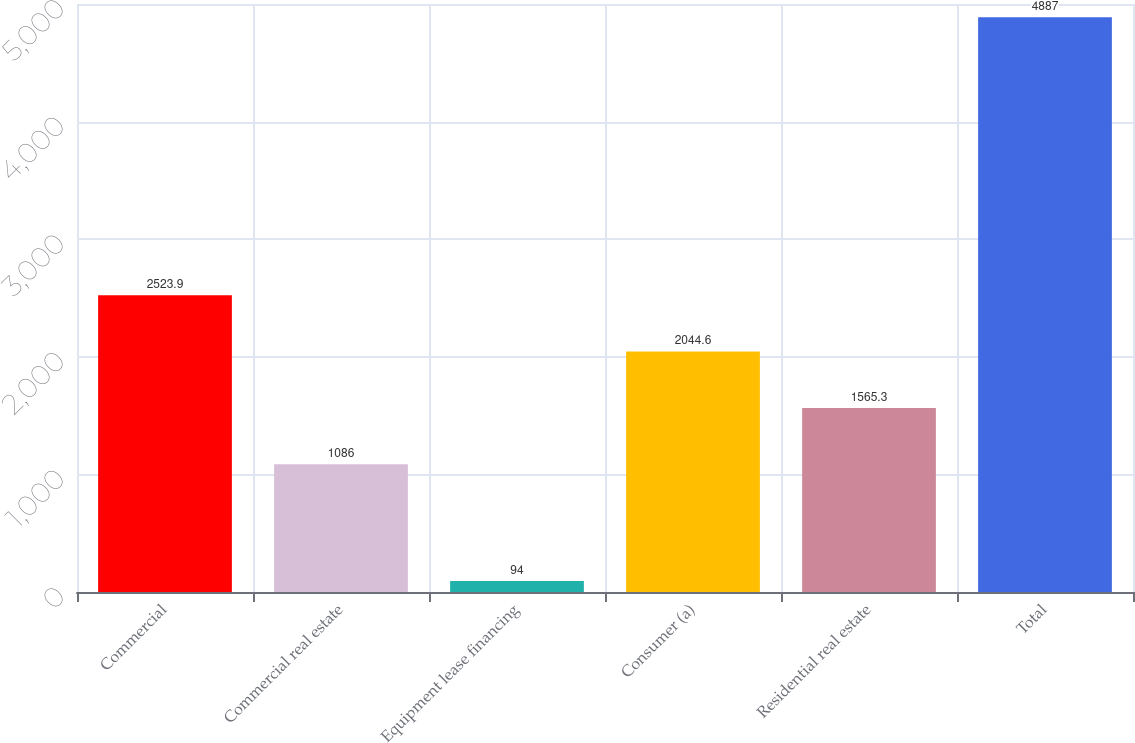Convert chart to OTSL. <chart><loc_0><loc_0><loc_500><loc_500><bar_chart><fcel>Commercial<fcel>Commercial real estate<fcel>Equipment lease financing<fcel>Consumer (a)<fcel>Residential real estate<fcel>Total<nl><fcel>2523.9<fcel>1086<fcel>94<fcel>2044.6<fcel>1565.3<fcel>4887<nl></chart> 